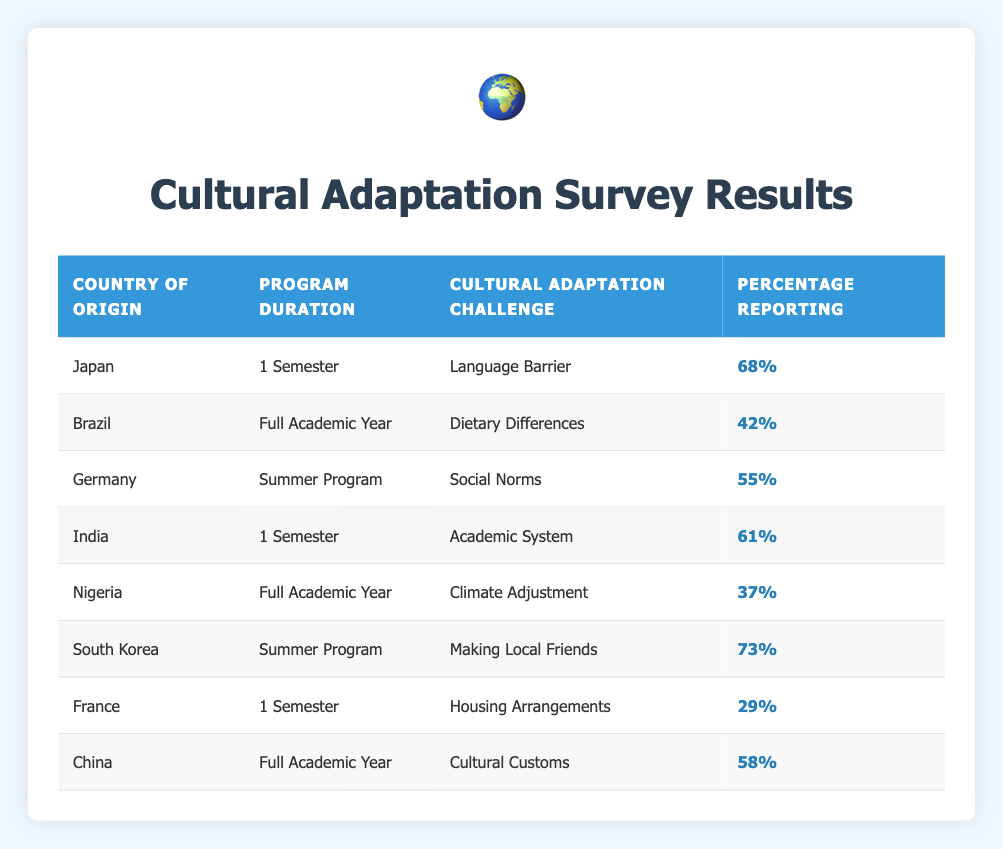What is the cultural adaptation challenge reported by participants from Japan? The table lists the cultural adaptation challenges alongside their respective country and program duration. For Japan, the challenge specified is related to "Language Barrier."
Answer: Language Barrier Which country reported the highest percentage for making local friends as a cultural challenge? Looking at the table, South Korea shows the highest percentage among the listed challenges for making local friends, which is 73%.
Answer: South Korea What is the average percentage of participants reporting challenges related to climate adjustment? Only Nigeria reported climate adjustment as a challenge with a percentage of 37%. Since there is only one data point, the average is simply 37%.
Answer: 37% Is it true that more than 50% of participants from Germany reported challenges related to social norms? The percentage reported for Germany regarding social norms is 55%, which is indeed greater than 50%.
Answer: Yes What is the difference in the percentage reporting between challenges of language barriers (Japan) and dietary differences (Brazil)? The percentage for Japan (language barriers) is 68% and for Brazil (dietary differences) is 42%. The difference is calculated as 68% - 42% = 26%.
Answer: 26% 